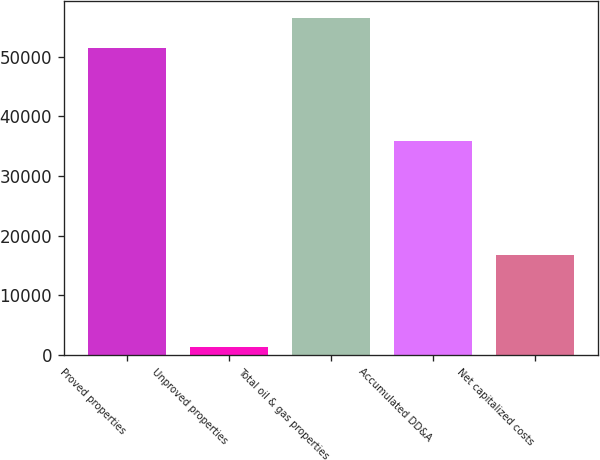Convert chart to OTSL. <chart><loc_0><loc_0><loc_500><loc_500><bar_chart><fcel>Proved properties<fcel>Unproved properties<fcel>Total oil & gas properties<fcel>Accumulated DD&A<fcel>Net capitalized costs<nl><fcel>51366<fcel>1277<fcel>56502.6<fcel>35848<fcel>16795<nl></chart> 